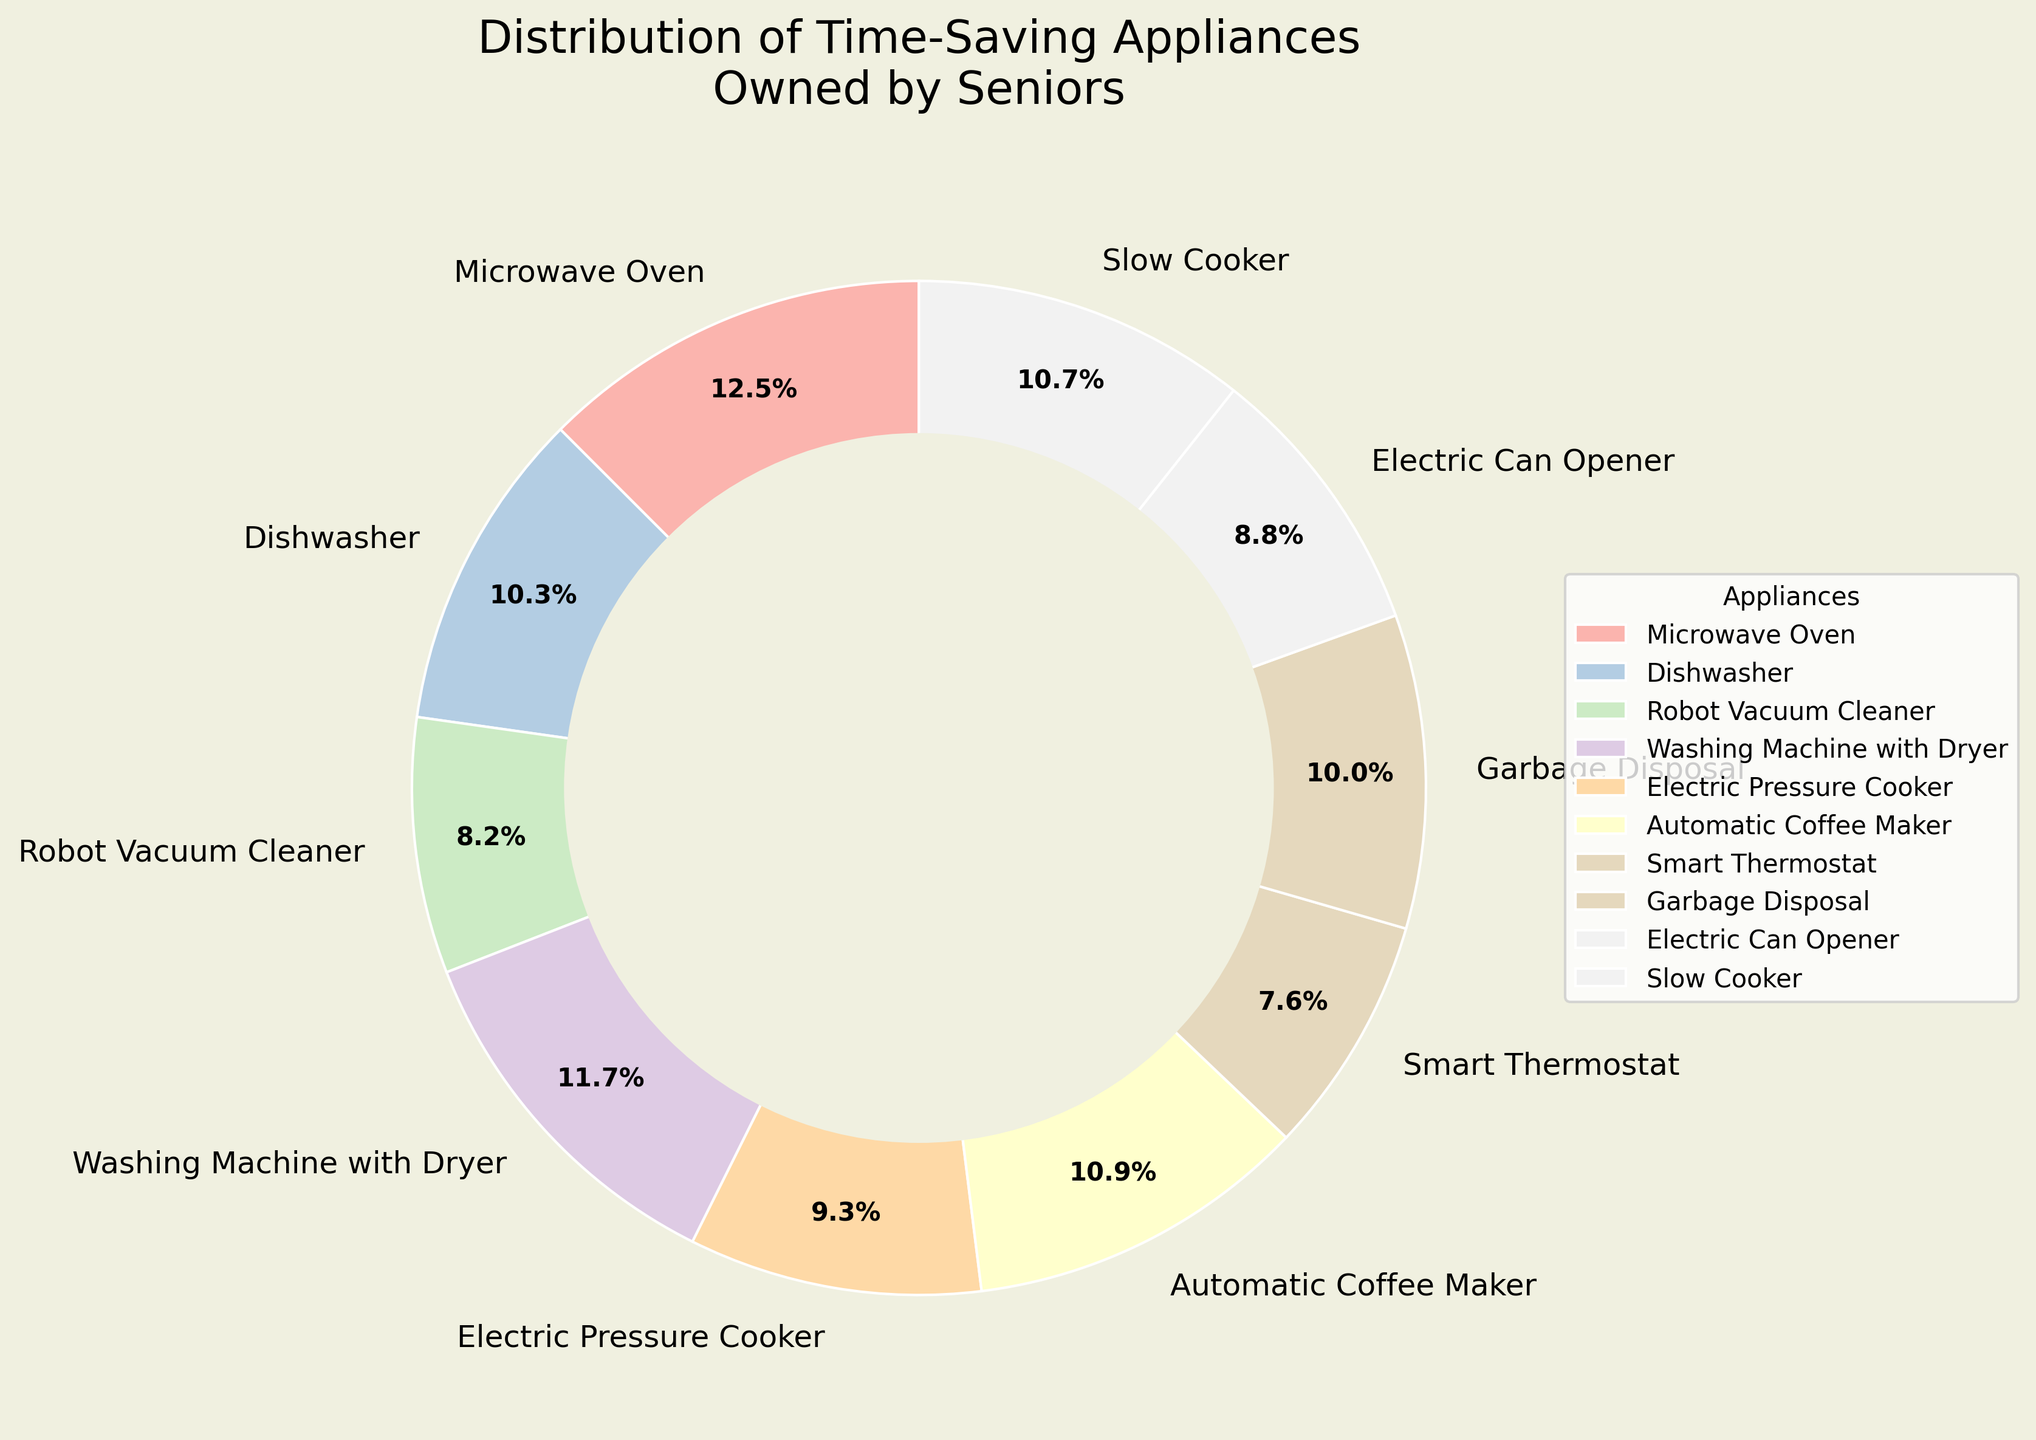Which appliance has the highest ownership percentage among seniors? The figure shows the distribution of various household appliances owned by seniors, and the appliance with the largest slice represents the highest ownership percentage.
Answer: Microwave Oven Which appliance has the lowest ownership percentage among seniors? By looking at the figure, the appliance with the smallest slice signifies the lowest ownership percentage.
Answer: Smart Thermostat What is the difference in ownership percentage between the Electric Can Opener and the Electric Pressure Cooker? The figure shows that the Electric Can Opener has an ownership percentage of 67%, and the Electric Pressure Cooker has 71%. The difference is calculated as 71% - 67%.
Answer: 4% How many appliances have an ownership percentage greater than 80%? To answer this, we need to count the number of slices with percentages greater than 80%. The appliances are Microwave Oven (95%), Washing Machine with Dryer (89%), and Automatic Coffee Maker (83%).
Answer: 3 What is the total percentage of ownership for the top three most popular appliances? The three most popular appliances by percentages can be identified as Microwave Oven (95%), Washing Machine with Dryer (89%), and Automatic Coffee Maker (83%). Summing these percentages: 95% + 89% + 83%.
Answer: 267% Which appliance has a higher ownership percentage, the Slow Cooker or the Dishwasher? By comparing the sizes of the slices, we see that the Slow Cooker's slice (81%) is larger than the Dishwasher's slice (78%).
Answer: Slow Cooker What is the average ownership percentage of the appliances? To find the average, sum all the ownership percentages and then divide by the number of appliances. The percentages are 95, 78, 62, 89, 71, 83, 58, 76, 67, 81. The sum is 760. The average is 760/10.
Answer: 76% What percentage of seniors own either a Robot Vacuum Cleaner or a Smart Thermostat? The ownership percentages for Robot Vacuum Cleaner and Smart Thermostat are 62% and 58%, respectively. Adding these percentages: 62% + 58%.
Answer: 120% Which appliances have ownership percentages between 70% and 80%? From the figure, we note the appliances within this range are the Electric Pressure Cooker (71%) and the Garbage Disposal (76%).
Answer: Electric Pressure Cooker, Garbage Disposal 